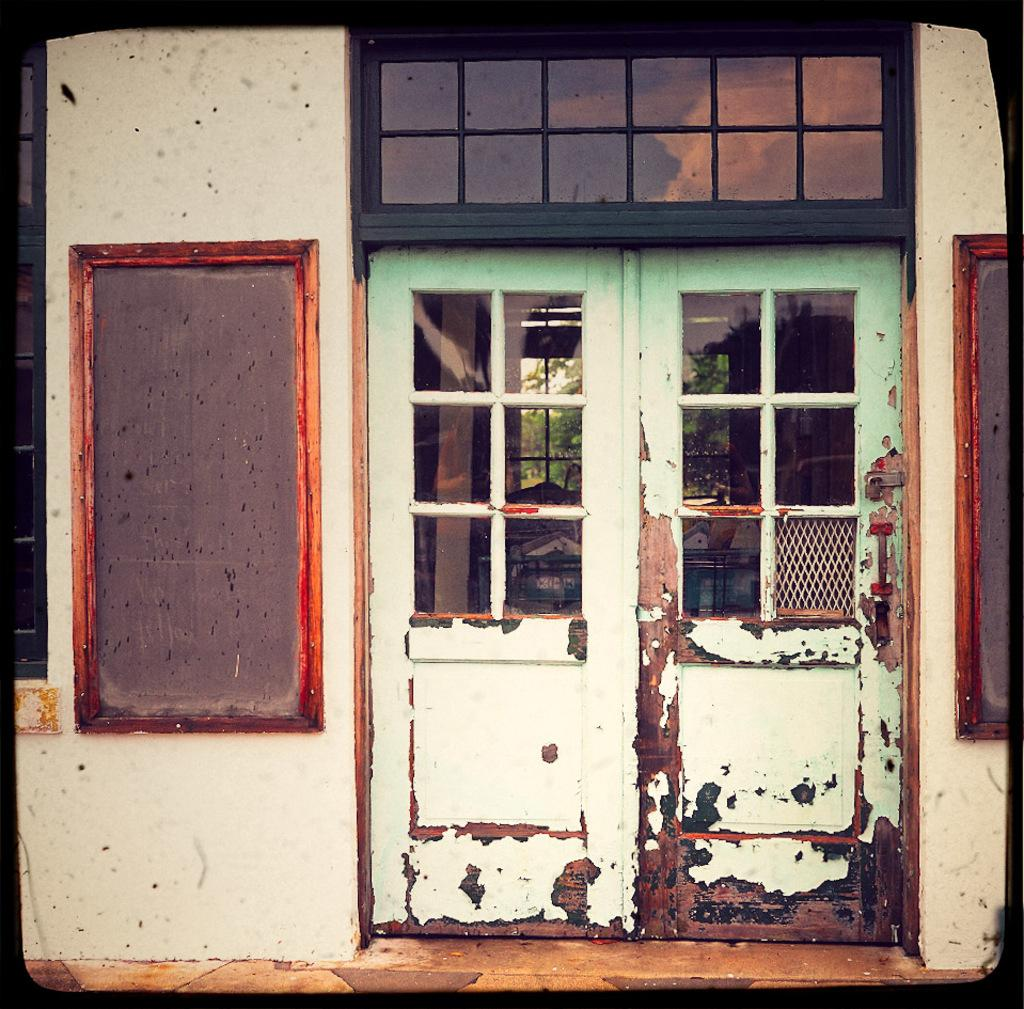What type of openings can be seen in the image? There are doors and a window in the image. What is attached to the wall in the image? There are boards attached to the wall in the image. What can be seen in the background of the image? Trees and other objects are visible in the background of the image. How many tomatoes are hanging from the trees in the image? There are no tomatoes visible in the image; only trees and other objects are present in the background. What type of teeth can be seen in the image? There are no teeth visible in the image. 